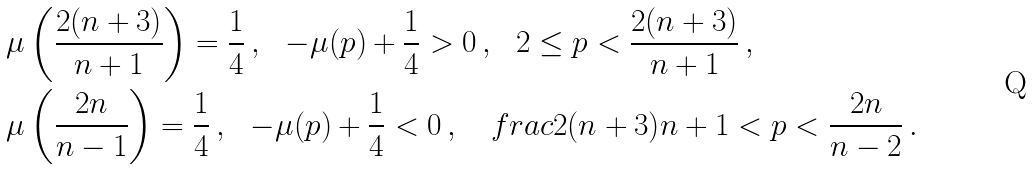<formula> <loc_0><loc_0><loc_500><loc_500>& \mu \left ( \frac { 2 ( n + 3 ) } { n + 1 } \right ) = \frac { 1 } { 4 } \, , \ \ - \mu ( p ) + \frac { 1 } { 4 } > 0 \, , \ \ 2 \leq p < \frac { 2 ( n + 3 ) } { n + 1 } \, , \\ & \mu \left ( \frac { 2 n } { n - 1 } \right ) = \frac { 1 } { 4 } \, , \ \ - \mu ( p ) + \frac { 1 } { 4 } < 0 \, , \ \ \ f r a c { 2 ( n + 3 ) } { n + 1 } < p < \frac { 2 n } { n - 2 } \, .</formula> 